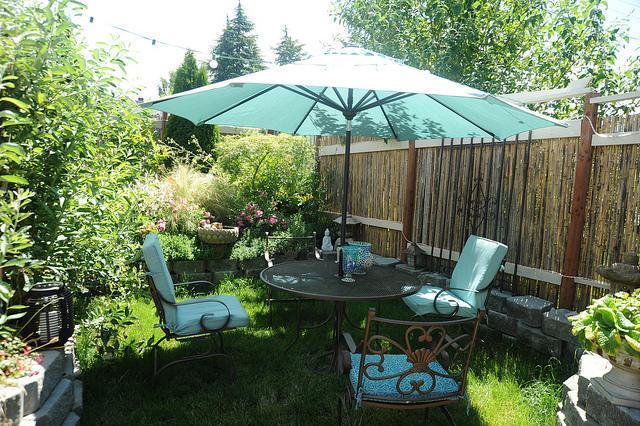How many dining tables are there?
Give a very brief answer. 1. How many chairs can you see?
Give a very brief answer. 3. 